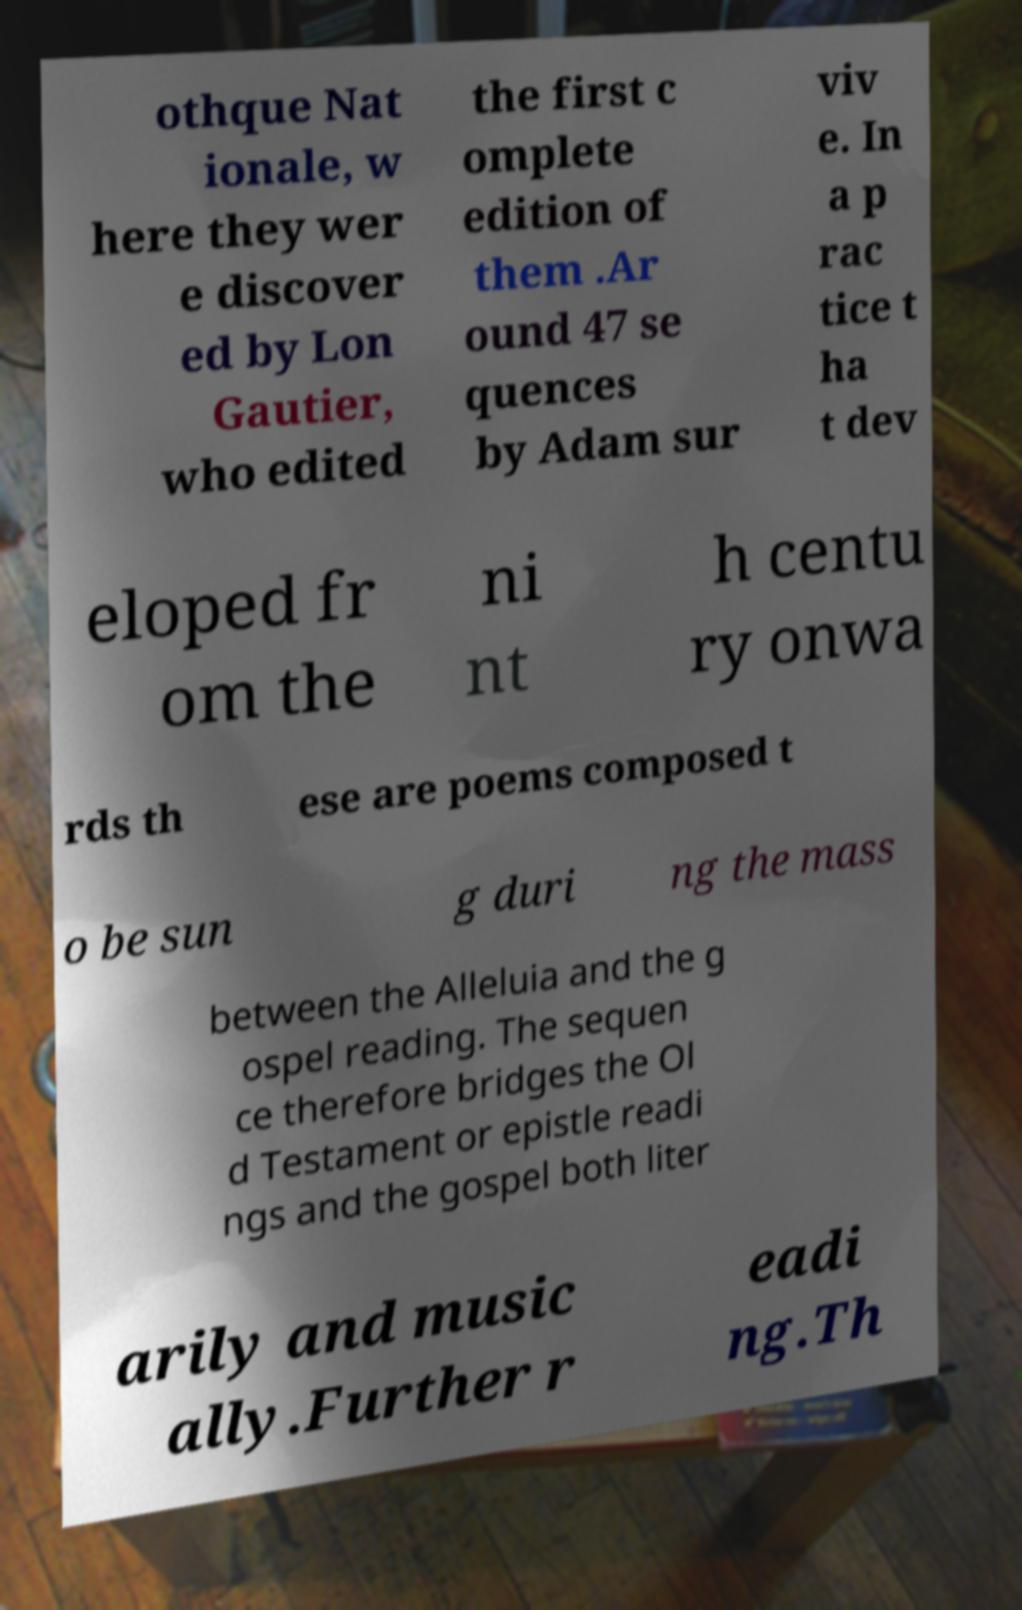Can you read and provide the text displayed in the image?This photo seems to have some interesting text. Can you extract and type it out for me? othque Nat ionale, w here they wer e discover ed by Lon Gautier, who edited the first c omplete edition of them .Ar ound 47 se quences by Adam sur viv e. In a p rac tice t ha t dev eloped fr om the ni nt h centu ry onwa rds th ese are poems composed t o be sun g duri ng the mass between the Alleluia and the g ospel reading. The sequen ce therefore bridges the Ol d Testament or epistle readi ngs and the gospel both liter arily and music ally.Further r eadi ng.Th 